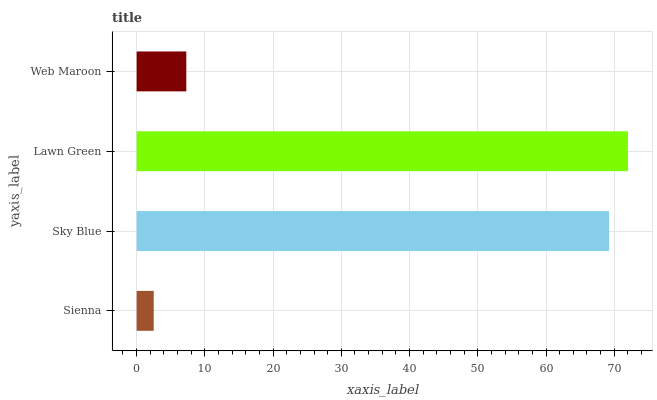Is Sienna the minimum?
Answer yes or no. Yes. Is Lawn Green the maximum?
Answer yes or no. Yes. Is Sky Blue the minimum?
Answer yes or no. No. Is Sky Blue the maximum?
Answer yes or no. No. Is Sky Blue greater than Sienna?
Answer yes or no. Yes. Is Sienna less than Sky Blue?
Answer yes or no. Yes. Is Sienna greater than Sky Blue?
Answer yes or no. No. Is Sky Blue less than Sienna?
Answer yes or no. No. Is Sky Blue the high median?
Answer yes or no. Yes. Is Web Maroon the low median?
Answer yes or no. Yes. Is Lawn Green the high median?
Answer yes or no. No. Is Sky Blue the low median?
Answer yes or no. No. 